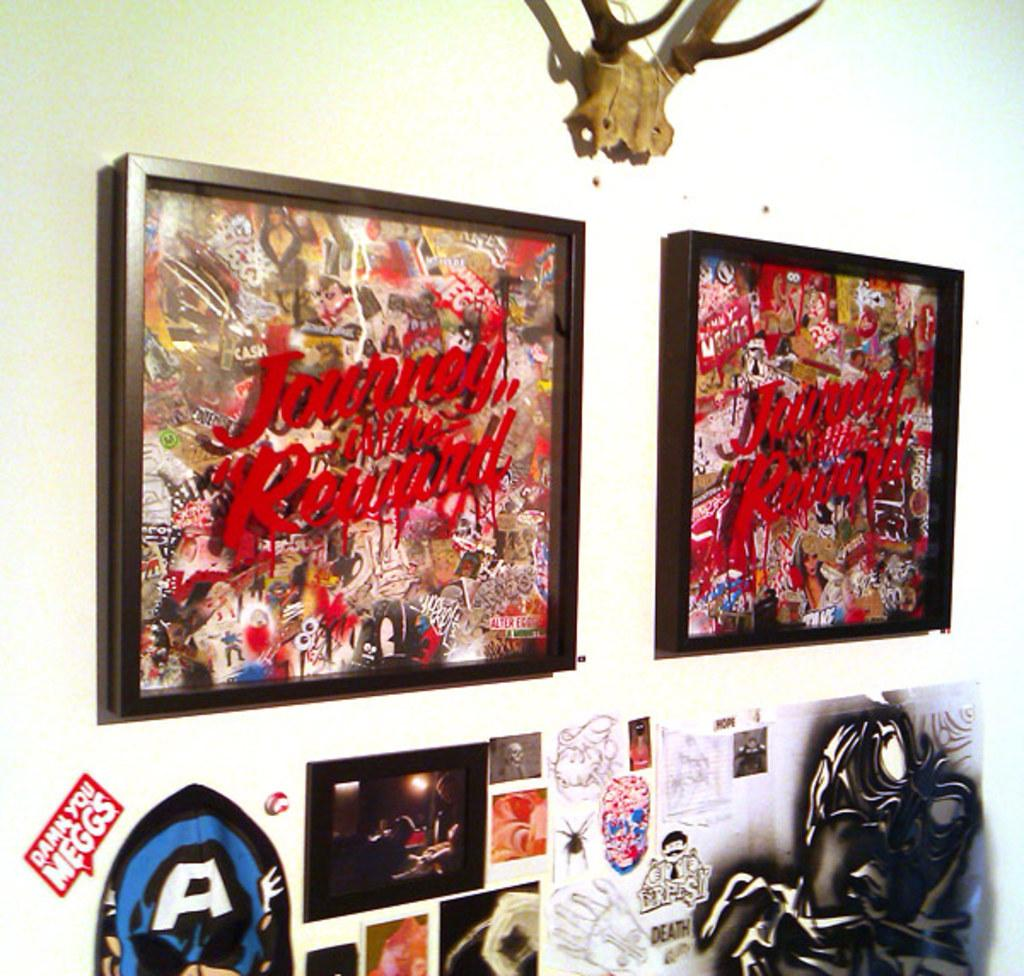What type of items can be seen on the wall in the image? There are photo frames and posters on the wall in the image. Are there any other objects on the wall besides photo frames and posters? Yes, there are other objects on the wall. What type of cheese can be seen on the pan in the image? There is no pan or cheese present in the image. 